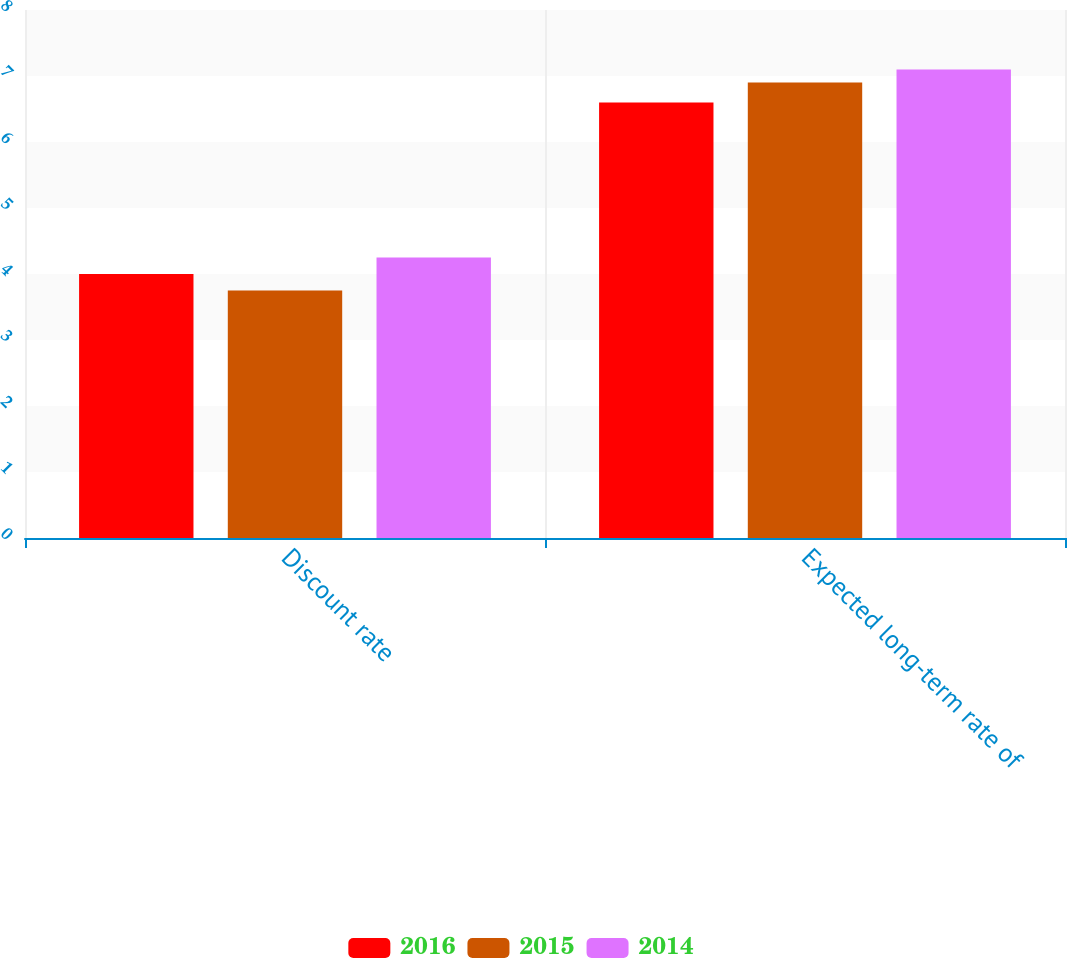Convert chart. <chart><loc_0><loc_0><loc_500><loc_500><stacked_bar_chart><ecel><fcel>Discount rate<fcel>Expected long-term rate of<nl><fcel>2016<fcel>4<fcel>6.6<nl><fcel>2015<fcel>3.75<fcel>6.9<nl><fcel>2014<fcel>4.25<fcel>7.1<nl></chart> 